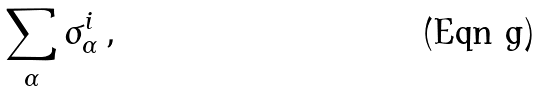Convert formula to latex. <formula><loc_0><loc_0><loc_500><loc_500>\sum _ { \alpha } \sigma ^ { i } _ { \alpha } \, ,</formula> 